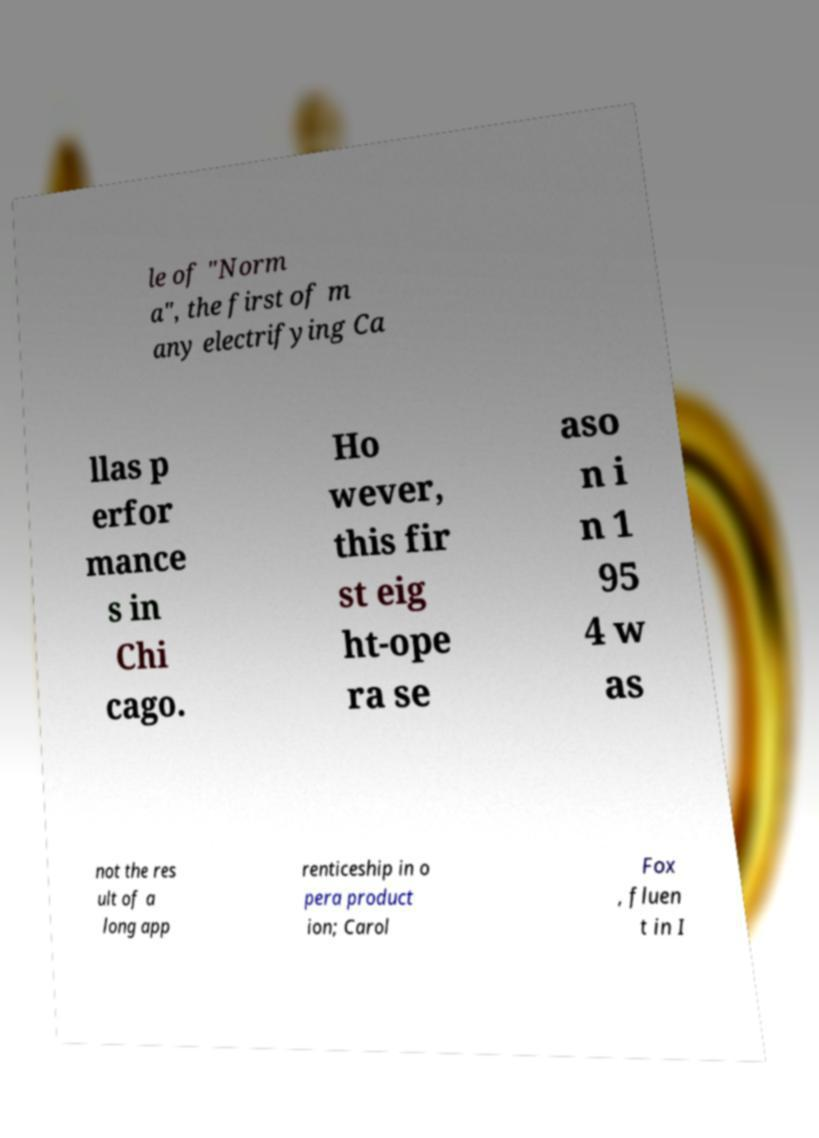Can you accurately transcribe the text from the provided image for me? le of "Norm a", the first of m any electrifying Ca llas p erfor mance s in Chi cago. Ho wever, this fir st eig ht-ope ra se aso n i n 1 95 4 w as not the res ult of a long app renticeship in o pera product ion; Carol Fox , fluen t in I 